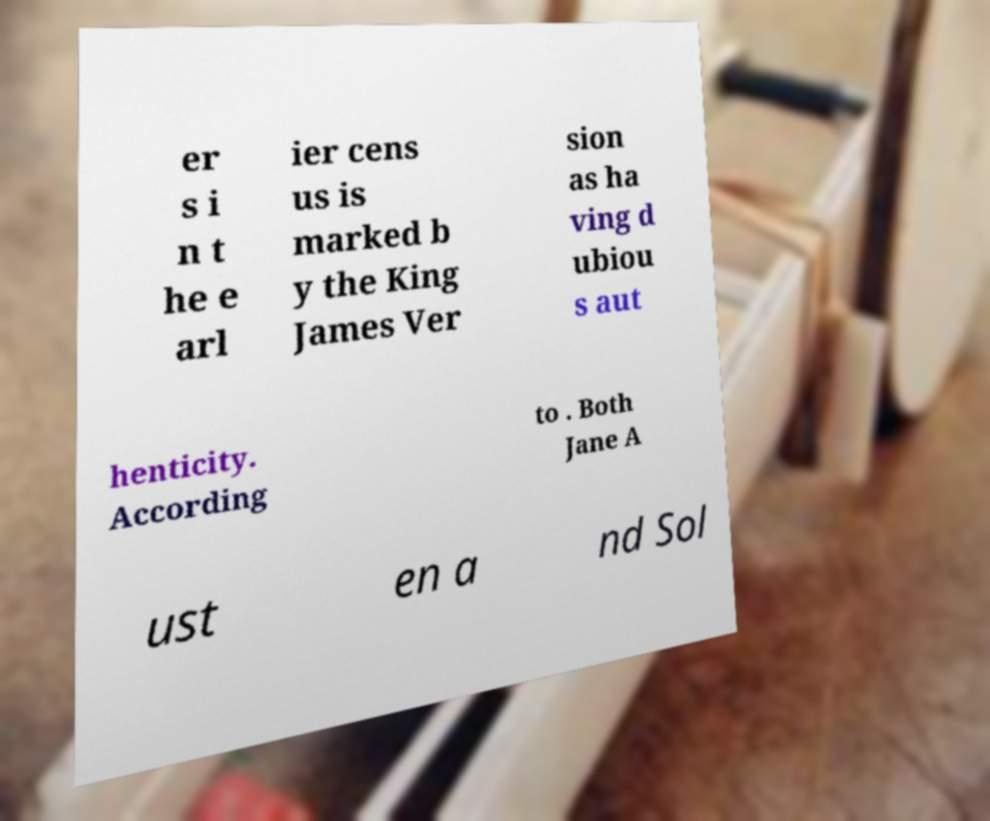Can you read and provide the text displayed in the image?This photo seems to have some interesting text. Can you extract and type it out for me? er s i n t he e arl ier cens us is marked b y the King James Ver sion as ha ving d ubiou s aut henticity. According to . Both Jane A ust en a nd Sol 